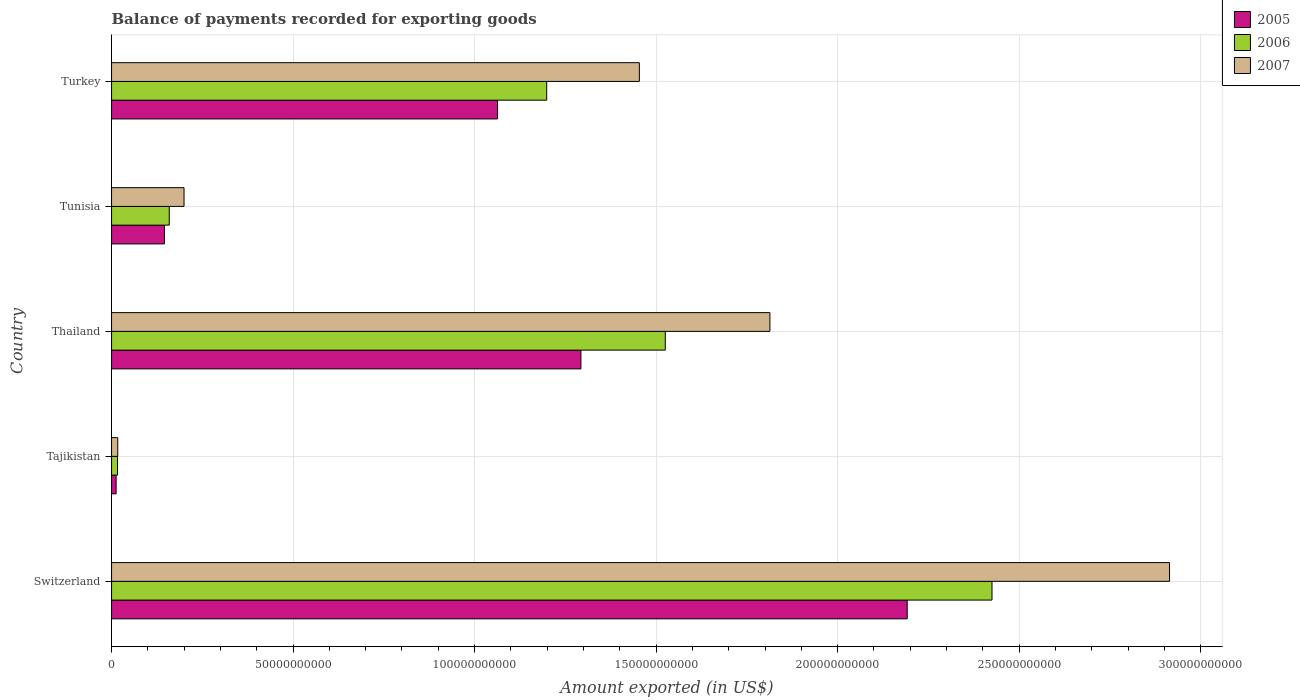How many different coloured bars are there?
Offer a very short reply. 3. Are the number of bars per tick equal to the number of legend labels?
Your answer should be very brief. Yes. Are the number of bars on each tick of the Y-axis equal?
Ensure brevity in your answer.  Yes. What is the label of the 2nd group of bars from the top?
Ensure brevity in your answer.  Tunisia. In how many cases, is the number of bars for a given country not equal to the number of legend labels?
Ensure brevity in your answer.  0. What is the amount exported in 2007 in Tajikistan?
Your response must be concise. 1.71e+09. Across all countries, what is the maximum amount exported in 2005?
Give a very brief answer. 2.19e+11. Across all countries, what is the minimum amount exported in 2005?
Make the answer very short. 1.25e+09. In which country was the amount exported in 2007 maximum?
Make the answer very short. Switzerland. In which country was the amount exported in 2007 minimum?
Keep it short and to the point. Tajikistan. What is the total amount exported in 2007 in the graph?
Offer a very short reply. 6.40e+11. What is the difference between the amount exported in 2006 in Switzerland and that in Tajikistan?
Your answer should be compact. 2.41e+11. What is the difference between the amount exported in 2006 in Turkey and the amount exported in 2005 in Tajikistan?
Provide a short and direct response. 1.19e+11. What is the average amount exported in 2005 per country?
Provide a succinct answer. 9.41e+1. What is the difference between the amount exported in 2005 and amount exported in 2006 in Tajikistan?
Your answer should be very brief. -3.92e+08. What is the ratio of the amount exported in 2005 in Tajikistan to that in Thailand?
Your answer should be very brief. 0.01. What is the difference between the highest and the second highest amount exported in 2007?
Give a very brief answer. 1.10e+11. What is the difference between the highest and the lowest amount exported in 2006?
Provide a succinct answer. 2.41e+11. In how many countries, is the amount exported in 2007 greater than the average amount exported in 2007 taken over all countries?
Ensure brevity in your answer.  3. What does the 1st bar from the top in Tajikistan represents?
Provide a short and direct response. 2007. Is it the case that in every country, the sum of the amount exported in 2007 and amount exported in 2005 is greater than the amount exported in 2006?
Provide a succinct answer. Yes. How many bars are there?
Keep it short and to the point. 15. Are all the bars in the graph horizontal?
Keep it short and to the point. Yes. How many countries are there in the graph?
Offer a terse response. 5. Where does the legend appear in the graph?
Ensure brevity in your answer.  Top right. How many legend labels are there?
Offer a terse response. 3. What is the title of the graph?
Offer a terse response. Balance of payments recorded for exporting goods. Does "2009" appear as one of the legend labels in the graph?
Provide a short and direct response. No. What is the label or title of the X-axis?
Offer a terse response. Amount exported (in US$). What is the Amount exported (in US$) in 2005 in Switzerland?
Your response must be concise. 2.19e+11. What is the Amount exported (in US$) of 2006 in Switzerland?
Ensure brevity in your answer.  2.43e+11. What is the Amount exported (in US$) of 2007 in Switzerland?
Your answer should be compact. 2.91e+11. What is the Amount exported (in US$) in 2005 in Tajikistan?
Your response must be concise. 1.25e+09. What is the Amount exported (in US$) of 2006 in Tajikistan?
Offer a very short reply. 1.65e+09. What is the Amount exported (in US$) of 2007 in Tajikistan?
Keep it short and to the point. 1.71e+09. What is the Amount exported (in US$) of 2005 in Thailand?
Give a very brief answer. 1.29e+11. What is the Amount exported (in US$) in 2006 in Thailand?
Offer a very short reply. 1.53e+11. What is the Amount exported (in US$) of 2007 in Thailand?
Give a very brief answer. 1.81e+11. What is the Amount exported (in US$) in 2005 in Tunisia?
Your answer should be very brief. 1.46e+1. What is the Amount exported (in US$) of 2006 in Tunisia?
Offer a terse response. 1.59e+1. What is the Amount exported (in US$) of 2007 in Tunisia?
Make the answer very short. 2.00e+1. What is the Amount exported (in US$) in 2005 in Turkey?
Your answer should be compact. 1.06e+11. What is the Amount exported (in US$) in 2006 in Turkey?
Your response must be concise. 1.20e+11. What is the Amount exported (in US$) in 2007 in Turkey?
Provide a succinct answer. 1.45e+11. Across all countries, what is the maximum Amount exported (in US$) in 2005?
Ensure brevity in your answer.  2.19e+11. Across all countries, what is the maximum Amount exported (in US$) of 2006?
Offer a terse response. 2.43e+11. Across all countries, what is the maximum Amount exported (in US$) in 2007?
Your answer should be very brief. 2.91e+11. Across all countries, what is the minimum Amount exported (in US$) of 2005?
Ensure brevity in your answer.  1.25e+09. Across all countries, what is the minimum Amount exported (in US$) of 2006?
Give a very brief answer. 1.65e+09. Across all countries, what is the minimum Amount exported (in US$) in 2007?
Give a very brief answer. 1.71e+09. What is the total Amount exported (in US$) of 2005 in the graph?
Offer a terse response. 4.71e+11. What is the total Amount exported (in US$) in 2006 in the graph?
Keep it short and to the point. 5.32e+11. What is the total Amount exported (in US$) of 2007 in the graph?
Provide a short and direct response. 6.40e+11. What is the difference between the Amount exported (in US$) in 2005 in Switzerland and that in Tajikistan?
Your response must be concise. 2.18e+11. What is the difference between the Amount exported (in US$) of 2006 in Switzerland and that in Tajikistan?
Give a very brief answer. 2.41e+11. What is the difference between the Amount exported (in US$) of 2007 in Switzerland and that in Tajikistan?
Make the answer very short. 2.90e+11. What is the difference between the Amount exported (in US$) of 2005 in Switzerland and that in Thailand?
Offer a terse response. 8.99e+1. What is the difference between the Amount exported (in US$) in 2006 in Switzerland and that in Thailand?
Offer a terse response. 9.00e+1. What is the difference between the Amount exported (in US$) of 2007 in Switzerland and that in Thailand?
Provide a succinct answer. 1.10e+11. What is the difference between the Amount exported (in US$) in 2005 in Switzerland and that in Tunisia?
Your response must be concise. 2.05e+11. What is the difference between the Amount exported (in US$) in 2006 in Switzerland and that in Tunisia?
Make the answer very short. 2.27e+11. What is the difference between the Amount exported (in US$) of 2007 in Switzerland and that in Tunisia?
Offer a very short reply. 2.71e+11. What is the difference between the Amount exported (in US$) in 2005 in Switzerland and that in Turkey?
Provide a short and direct response. 1.13e+11. What is the difference between the Amount exported (in US$) in 2006 in Switzerland and that in Turkey?
Your answer should be compact. 1.23e+11. What is the difference between the Amount exported (in US$) in 2007 in Switzerland and that in Turkey?
Your answer should be compact. 1.46e+11. What is the difference between the Amount exported (in US$) in 2005 in Tajikistan and that in Thailand?
Offer a very short reply. -1.28e+11. What is the difference between the Amount exported (in US$) of 2006 in Tajikistan and that in Thailand?
Provide a succinct answer. -1.51e+11. What is the difference between the Amount exported (in US$) in 2007 in Tajikistan and that in Thailand?
Provide a succinct answer. -1.80e+11. What is the difference between the Amount exported (in US$) of 2005 in Tajikistan and that in Tunisia?
Make the answer very short. -1.33e+1. What is the difference between the Amount exported (in US$) of 2006 in Tajikistan and that in Tunisia?
Your answer should be compact. -1.42e+1. What is the difference between the Amount exported (in US$) of 2007 in Tajikistan and that in Tunisia?
Offer a very short reply. -1.83e+1. What is the difference between the Amount exported (in US$) of 2005 in Tajikistan and that in Turkey?
Offer a very short reply. -1.05e+11. What is the difference between the Amount exported (in US$) in 2006 in Tajikistan and that in Turkey?
Offer a very short reply. -1.18e+11. What is the difference between the Amount exported (in US$) of 2007 in Tajikistan and that in Turkey?
Your answer should be very brief. -1.44e+11. What is the difference between the Amount exported (in US$) of 2005 in Thailand and that in Tunisia?
Offer a very short reply. 1.15e+11. What is the difference between the Amount exported (in US$) of 2006 in Thailand and that in Tunisia?
Make the answer very short. 1.37e+11. What is the difference between the Amount exported (in US$) of 2007 in Thailand and that in Tunisia?
Provide a short and direct response. 1.61e+11. What is the difference between the Amount exported (in US$) in 2005 in Thailand and that in Turkey?
Your answer should be very brief. 2.30e+1. What is the difference between the Amount exported (in US$) of 2006 in Thailand and that in Turkey?
Make the answer very short. 3.27e+1. What is the difference between the Amount exported (in US$) of 2007 in Thailand and that in Turkey?
Provide a short and direct response. 3.60e+1. What is the difference between the Amount exported (in US$) in 2005 in Tunisia and that in Turkey?
Your response must be concise. -9.18e+1. What is the difference between the Amount exported (in US$) in 2006 in Tunisia and that in Turkey?
Your answer should be compact. -1.04e+11. What is the difference between the Amount exported (in US$) in 2007 in Tunisia and that in Turkey?
Provide a short and direct response. -1.25e+11. What is the difference between the Amount exported (in US$) of 2005 in Switzerland and the Amount exported (in US$) of 2006 in Tajikistan?
Make the answer very short. 2.18e+11. What is the difference between the Amount exported (in US$) in 2005 in Switzerland and the Amount exported (in US$) in 2007 in Tajikistan?
Provide a short and direct response. 2.17e+11. What is the difference between the Amount exported (in US$) in 2006 in Switzerland and the Amount exported (in US$) in 2007 in Tajikistan?
Your response must be concise. 2.41e+11. What is the difference between the Amount exported (in US$) in 2005 in Switzerland and the Amount exported (in US$) in 2006 in Thailand?
Keep it short and to the point. 6.66e+1. What is the difference between the Amount exported (in US$) in 2005 in Switzerland and the Amount exported (in US$) in 2007 in Thailand?
Keep it short and to the point. 3.78e+1. What is the difference between the Amount exported (in US$) in 2006 in Switzerland and the Amount exported (in US$) in 2007 in Thailand?
Give a very brief answer. 6.12e+1. What is the difference between the Amount exported (in US$) of 2005 in Switzerland and the Amount exported (in US$) of 2006 in Tunisia?
Give a very brief answer. 2.03e+11. What is the difference between the Amount exported (in US$) of 2005 in Switzerland and the Amount exported (in US$) of 2007 in Tunisia?
Your answer should be compact. 1.99e+11. What is the difference between the Amount exported (in US$) in 2006 in Switzerland and the Amount exported (in US$) in 2007 in Tunisia?
Ensure brevity in your answer.  2.23e+11. What is the difference between the Amount exported (in US$) of 2005 in Switzerland and the Amount exported (in US$) of 2006 in Turkey?
Your response must be concise. 9.93e+1. What is the difference between the Amount exported (in US$) of 2005 in Switzerland and the Amount exported (in US$) of 2007 in Turkey?
Your answer should be compact. 7.38e+1. What is the difference between the Amount exported (in US$) in 2006 in Switzerland and the Amount exported (in US$) in 2007 in Turkey?
Offer a very short reply. 9.71e+1. What is the difference between the Amount exported (in US$) of 2005 in Tajikistan and the Amount exported (in US$) of 2006 in Thailand?
Provide a succinct answer. -1.51e+11. What is the difference between the Amount exported (in US$) of 2005 in Tajikistan and the Amount exported (in US$) of 2007 in Thailand?
Provide a succinct answer. -1.80e+11. What is the difference between the Amount exported (in US$) in 2006 in Tajikistan and the Amount exported (in US$) in 2007 in Thailand?
Make the answer very short. -1.80e+11. What is the difference between the Amount exported (in US$) in 2005 in Tajikistan and the Amount exported (in US$) in 2006 in Tunisia?
Provide a succinct answer. -1.46e+1. What is the difference between the Amount exported (in US$) of 2005 in Tajikistan and the Amount exported (in US$) of 2007 in Tunisia?
Ensure brevity in your answer.  -1.87e+1. What is the difference between the Amount exported (in US$) in 2006 in Tajikistan and the Amount exported (in US$) in 2007 in Tunisia?
Keep it short and to the point. -1.83e+1. What is the difference between the Amount exported (in US$) of 2005 in Tajikistan and the Amount exported (in US$) of 2006 in Turkey?
Provide a succinct answer. -1.19e+11. What is the difference between the Amount exported (in US$) of 2005 in Tajikistan and the Amount exported (in US$) of 2007 in Turkey?
Your answer should be very brief. -1.44e+11. What is the difference between the Amount exported (in US$) in 2006 in Tajikistan and the Amount exported (in US$) in 2007 in Turkey?
Your answer should be compact. -1.44e+11. What is the difference between the Amount exported (in US$) of 2005 in Thailand and the Amount exported (in US$) of 2006 in Tunisia?
Keep it short and to the point. 1.13e+11. What is the difference between the Amount exported (in US$) in 2005 in Thailand and the Amount exported (in US$) in 2007 in Tunisia?
Ensure brevity in your answer.  1.09e+11. What is the difference between the Amount exported (in US$) in 2006 in Thailand and the Amount exported (in US$) in 2007 in Tunisia?
Keep it short and to the point. 1.33e+11. What is the difference between the Amount exported (in US$) of 2005 in Thailand and the Amount exported (in US$) of 2006 in Turkey?
Make the answer very short. 9.43e+09. What is the difference between the Amount exported (in US$) in 2005 in Thailand and the Amount exported (in US$) in 2007 in Turkey?
Your answer should be compact. -1.61e+1. What is the difference between the Amount exported (in US$) in 2006 in Thailand and the Amount exported (in US$) in 2007 in Turkey?
Provide a short and direct response. 7.15e+09. What is the difference between the Amount exported (in US$) in 2005 in Tunisia and the Amount exported (in US$) in 2006 in Turkey?
Offer a terse response. -1.05e+11. What is the difference between the Amount exported (in US$) of 2005 in Tunisia and the Amount exported (in US$) of 2007 in Turkey?
Provide a short and direct response. -1.31e+11. What is the difference between the Amount exported (in US$) of 2006 in Tunisia and the Amount exported (in US$) of 2007 in Turkey?
Ensure brevity in your answer.  -1.29e+11. What is the average Amount exported (in US$) of 2005 per country?
Ensure brevity in your answer.  9.41e+1. What is the average Amount exported (in US$) of 2006 per country?
Your answer should be compact. 1.06e+11. What is the average Amount exported (in US$) in 2007 per country?
Offer a terse response. 1.28e+11. What is the difference between the Amount exported (in US$) of 2005 and Amount exported (in US$) of 2006 in Switzerland?
Offer a terse response. -2.34e+1. What is the difference between the Amount exported (in US$) of 2005 and Amount exported (in US$) of 2007 in Switzerland?
Provide a short and direct response. -7.23e+1. What is the difference between the Amount exported (in US$) in 2006 and Amount exported (in US$) in 2007 in Switzerland?
Your answer should be very brief. -4.89e+1. What is the difference between the Amount exported (in US$) of 2005 and Amount exported (in US$) of 2006 in Tajikistan?
Keep it short and to the point. -3.92e+08. What is the difference between the Amount exported (in US$) in 2005 and Amount exported (in US$) in 2007 in Tajikistan?
Offer a terse response. -4.51e+08. What is the difference between the Amount exported (in US$) in 2006 and Amount exported (in US$) in 2007 in Tajikistan?
Provide a short and direct response. -5.96e+07. What is the difference between the Amount exported (in US$) of 2005 and Amount exported (in US$) of 2006 in Thailand?
Your answer should be compact. -2.32e+1. What is the difference between the Amount exported (in US$) in 2005 and Amount exported (in US$) in 2007 in Thailand?
Provide a short and direct response. -5.21e+1. What is the difference between the Amount exported (in US$) of 2006 and Amount exported (in US$) of 2007 in Thailand?
Ensure brevity in your answer.  -2.88e+1. What is the difference between the Amount exported (in US$) in 2005 and Amount exported (in US$) in 2006 in Tunisia?
Offer a very short reply. -1.32e+09. What is the difference between the Amount exported (in US$) in 2005 and Amount exported (in US$) in 2007 in Tunisia?
Provide a short and direct response. -5.40e+09. What is the difference between the Amount exported (in US$) in 2006 and Amount exported (in US$) in 2007 in Tunisia?
Your response must be concise. -4.07e+09. What is the difference between the Amount exported (in US$) in 2005 and Amount exported (in US$) in 2006 in Turkey?
Ensure brevity in your answer.  -1.35e+1. What is the difference between the Amount exported (in US$) in 2005 and Amount exported (in US$) in 2007 in Turkey?
Your answer should be very brief. -3.91e+1. What is the difference between the Amount exported (in US$) in 2006 and Amount exported (in US$) in 2007 in Turkey?
Your answer should be compact. -2.55e+1. What is the ratio of the Amount exported (in US$) of 2005 in Switzerland to that in Tajikistan?
Your answer should be very brief. 174.72. What is the ratio of the Amount exported (in US$) of 2006 in Switzerland to that in Tajikistan?
Give a very brief answer. 147.34. What is the ratio of the Amount exported (in US$) of 2007 in Switzerland to that in Tajikistan?
Your answer should be very brief. 170.87. What is the ratio of the Amount exported (in US$) in 2005 in Switzerland to that in Thailand?
Give a very brief answer. 1.7. What is the ratio of the Amount exported (in US$) in 2006 in Switzerland to that in Thailand?
Make the answer very short. 1.59. What is the ratio of the Amount exported (in US$) of 2007 in Switzerland to that in Thailand?
Offer a terse response. 1.61. What is the ratio of the Amount exported (in US$) of 2005 in Switzerland to that in Tunisia?
Make the answer very short. 15.04. What is the ratio of the Amount exported (in US$) in 2006 in Switzerland to that in Tunisia?
Provide a succinct answer. 15.26. What is the ratio of the Amount exported (in US$) of 2007 in Switzerland to that in Tunisia?
Offer a terse response. 14.6. What is the ratio of the Amount exported (in US$) of 2005 in Switzerland to that in Turkey?
Provide a short and direct response. 2.06. What is the ratio of the Amount exported (in US$) of 2006 in Switzerland to that in Turkey?
Keep it short and to the point. 2.02. What is the ratio of the Amount exported (in US$) in 2007 in Switzerland to that in Turkey?
Your answer should be compact. 2. What is the ratio of the Amount exported (in US$) in 2005 in Tajikistan to that in Thailand?
Offer a very short reply. 0.01. What is the ratio of the Amount exported (in US$) in 2006 in Tajikistan to that in Thailand?
Keep it short and to the point. 0.01. What is the ratio of the Amount exported (in US$) of 2007 in Tajikistan to that in Thailand?
Offer a terse response. 0.01. What is the ratio of the Amount exported (in US$) of 2005 in Tajikistan to that in Tunisia?
Offer a terse response. 0.09. What is the ratio of the Amount exported (in US$) of 2006 in Tajikistan to that in Tunisia?
Your answer should be compact. 0.1. What is the ratio of the Amount exported (in US$) in 2007 in Tajikistan to that in Tunisia?
Your answer should be compact. 0.09. What is the ratio of the Amount exported (in US$) in 2005 in Tajikistan to that in Turkey?
Provide a succinct answer. 0.01. What is the ratio of the Amount exported (in US$) of 2006 in Tajikistan to that in Turkey?
Offer a terse response. 0.01. What is the ratio of the Amount exported (in US$) of 2007 in Tajikistan to that in Turkey?
Your answer should be compact. 0.01. What is the ratio of the Amount exported (in US$) in 2005 in Thailand to that in Tunisia?
Keep it short and to the point. 8.88. What is the ratio of the Amount exported (in US$) of 2006 in Thailand to that in Tunisia?
Provide a succinct answer. 9.6. What is the ratio of the Amount exported (in US$) of 2007 in Thailand to that in Tunisia?
Keep it short and to the point. 9.08. What is the ratio of the Amount exported (in US$) of 2005 in Thailand to that in Turkey?
Your answer should be compact. 1.22. What is the ratio of the Amount exported (in US$) in 2006 in Thailand to that in Turkey?
Ensure brevity in your answer.  1.27. What is the ratio of the Amount exported (in US$) of 2007 in Thailand to that in Turkey?
Ensure brevity in your answer.  1.25. What is the ratio of the Amount exported (in US$) in 2005 in Tunisia to that in Turkey?
Offer a very short reply. 0.14. What is the ratio of the Amount exported (in US$) in 2006 in Tunisia to that in Turkey?
Provide a succinct answer. 0.13. What is the ratio of the Amount exported (in US$) in 2007 in Tunisia to that in Turkey?
Offer a terse response. 0.14. What is the difference between the highest and the second highest Amount exported (in US$) of 2005?
Your answer should be very brief. 8.99e+1. What is the difference between the highest and the second highest Amount exported (in US$) in 2006?
Your answer should be compact. 9.00e+1. What is the difference between the highest and the second highest Amount exported (in US$) in 2007?
Your answer should be compact. 1.10e+11. What is the difference between the highest and the lowest Amount exported (in US$) of 2005?
Provide a short and direct response. 2.18e+11. What is the difference between the highest and the lowest Amount exported (in US$) of 2006?
Give a very brief answer. 2.41e+11. What is the difference between the highest and the lowest Amount exported (in US$) in 2007?
Provide a short and direct response. 2.90e+11. 